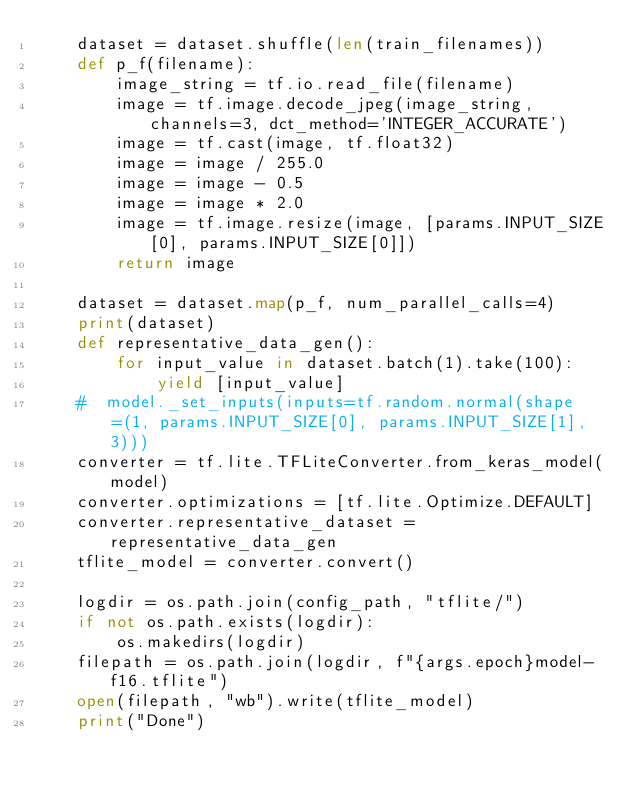Convert code to text. <code><loc_0><loc_0><loc_500><loc_500><_Python_>    dataset = dataset.shuffle(len(train_filenames))
    def p_f(filename):
        image_string = tf.io.read_file(filename)
        image = tf.image.decode_jpeg(image_string, channels=3, dct_method='INTEGER_ACCURATE')
        image = tf.cast(image, tf.float32)
        image = image / 255.0
        image = image - 0.5
        image = image * 2.0
        image = tf.image.resize(image, [params.INPUT_SIZE[0], params.INPUT_SIZE[0]])
        return image 

    dataset = dataset.map(p_f, num_parallel_calls=4)
    print(dataset)
    def representative_data_gen():
        for input_value in dataset.batch(1).take(100):
            yield [input_value]
    #  model._set_inputs(inputs=tf.random.normal(shape=(1, params.INPUT_SIZE[0], params.INPUT_SIZE[1], 3)))
    converter = tf.lite.TFLiteConverter.from_keras_model(model)
    converter.optimizations = [tf.lite.Optimize.DEFAULT]
    converter.representative_dataset = representative_data_gen
    tflite_model = converter.convert()

    logdir = os.path.join(config_path, "tflite/")
    if not os.path.exists(logdir):
        os.makedirs(logdir)
    filepath = os.path.join(logdir, f"{args.epoch}model-f16.tflite")
    open(filepath, "wb").write(tflite_model)
    print("Done")
</code> 